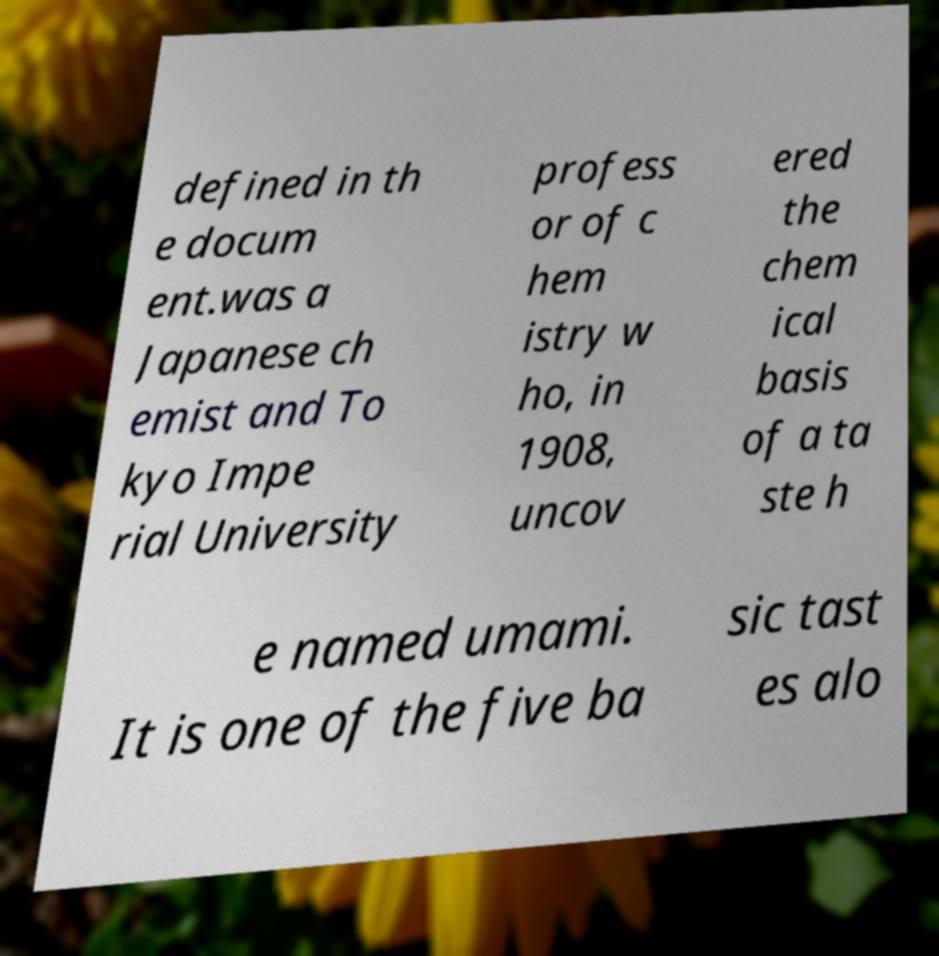Please read and relay the text visible in this image. What does it say? defined in th e docum ent.was a Japanese ch emist and To kyo Impe rial University profess or of c hem istry w ho, in 1908, uncov ered the chem ical basis of a ta ste h e named umami. It is one of the five ba sic tast es alo 